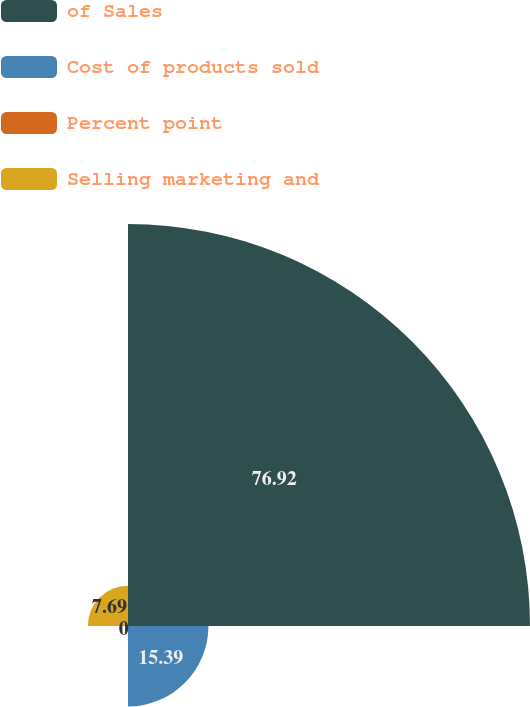Convert chart. <chart><loc_0><loc_0><loc_500><loc_500><pie_chart><fcel>of Sales<fcel>Cost of products sold<fcel>Percent point<fcel>Selling marketing and<nl><fcel>76.92%<fcel>15.39%<fcel>0.0%<fcel>7.69%<nl></chart> 